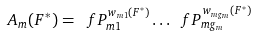<formula> <loc_0><loc_0><loc_500><loc_500>\ A _ { m } ( F ^ { * } ) = \ f P _ { m 1 } ^ { w _ { m 1 } ( F ^ { * } ) } \dots \ f P _ { m g _ { m } } ^ { w _ { m g _ { m } } ( F ^ { * } ) }</formula> 